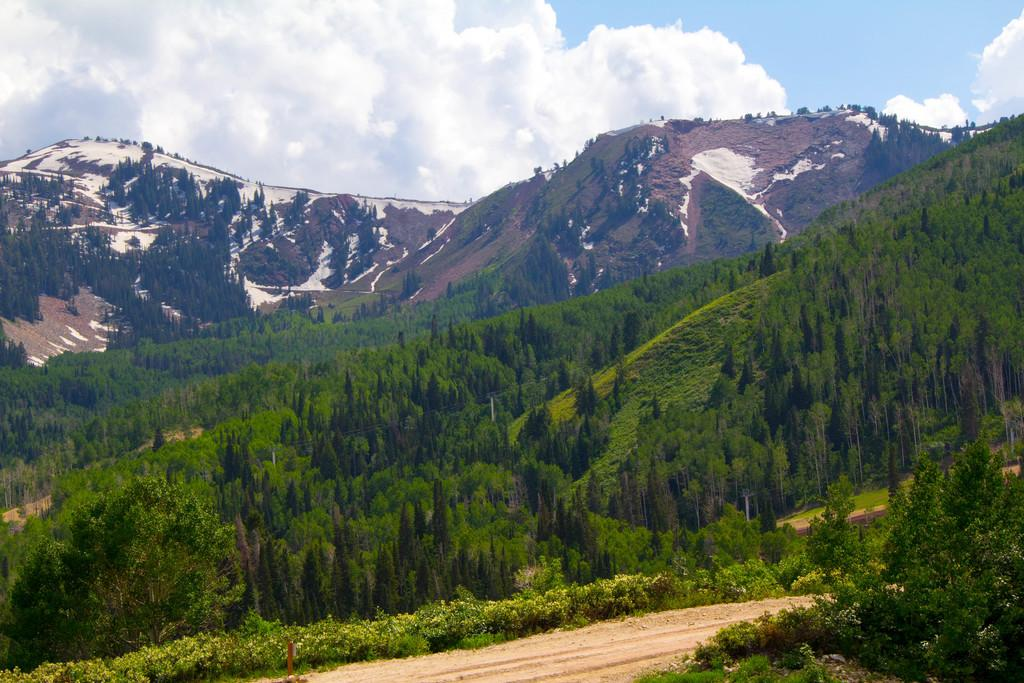What type of vegetation can be seen in the image? There are trees and plants in the image. What type of ground surface is visible in the image? There is a road and grass in the image. What type of terrain is visible in the image? There are hills in the image. What is visible in the sky in the image? The sky is visible in the image, along with clouds. What type of curtain can be seen hanging from the trees in the image? There is no curtain present in the image; it features trees, plants, a road, grass, hills, the sky, and clouds. What type of friction can be observed between the clouds and the hills in the image? There is no friction present in the image, as friction is a physical property and not a visible object or feature. How many lizards can be seen crawling on the grass in the image? There are no lizards present in the image. 